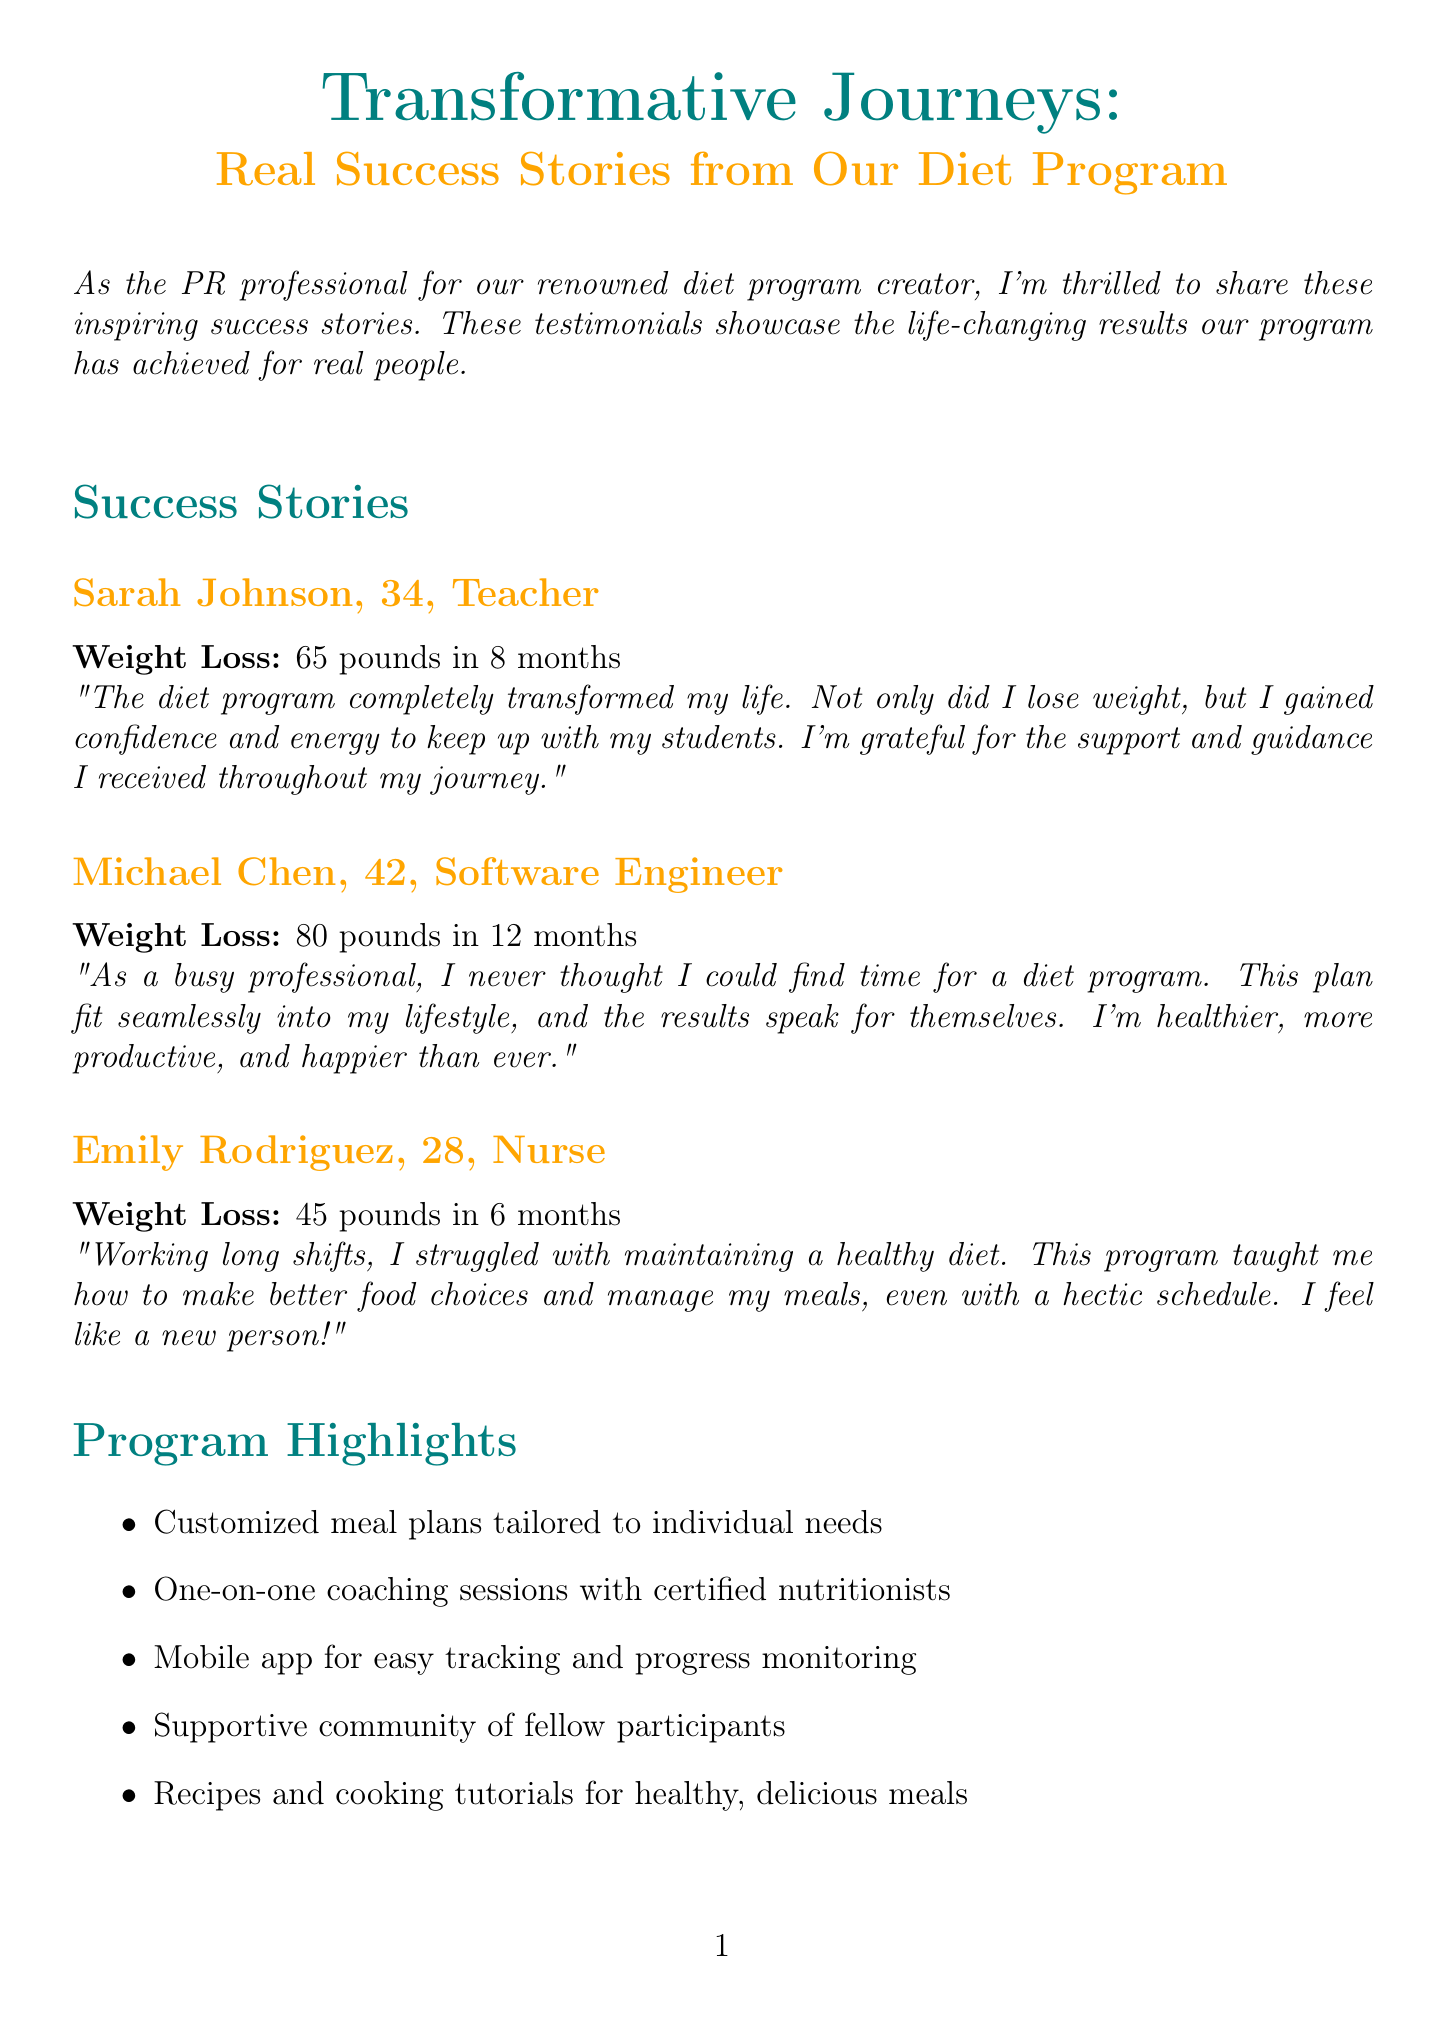What is the title of the newsletter? The title of the newsletter is the main heading presented at the top of the document.
Answer: Transformative Journeys: Real Success Stories from Our Diet Program How many pounds did Sarah Johnson lose? This information is found in Sarah Johnson's success story section, detailing her weight loss.
Answer: 65 pounds What was the time frame for Michael Chen's weight loss? This is stated in his success story, indicating how long it took for him to achieve his weight loss.
Answer: 12 months What is one highlight of the diet program? This information can be found in the section that lists the program's features.
Answer: Customized meal plans tailored to individual needs Which media outlet featured the diet program creator? This is mentioned in the media coverage section, identifying the source that highlighted the program.
Answer: Good Morning America Who is the creator of the diet program? The creator's name is mentioned in the "About the Creator" section at the end of the document.
Answer: Dr. Amanda Simmons How many success stories are featured in the newsletter? This information can be determined by counting the individual success stories provided in the document.
Answer: 3 What kind of support does the program offer? This is mentioned in the program highlights, specifically referring to one of the program's features.
Answer: Supportive community of fellow participants What is the call to action in the newsletter? This is the part of the document that encourages readers to take the next step and provides contact information.
Answer: Ready to start your own transformation journey? Visit our website or call 1-800-DIET-NOW 